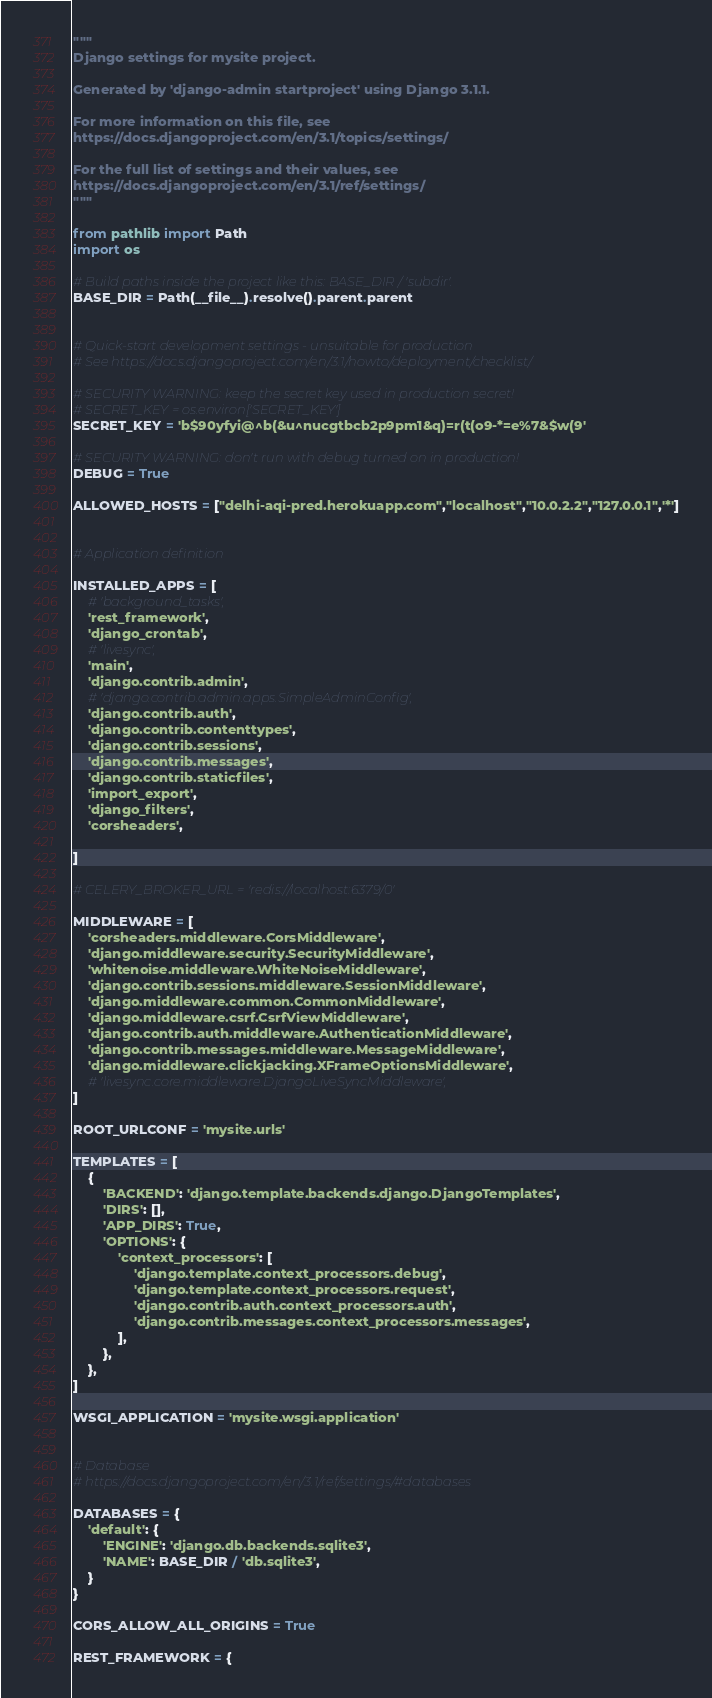<code> <loc_0><loc_0><loc_500><loc_500><_Python_>"""
Django settings for mysite project.

Generated by 'django-admin startproject' using Django 3.1.1.

For more information on this file, see
https://docs.djangoproject.com/en/3.1/topics/settings/

For the full list of settings and their values, see
https://docs.djangoproject.com/en/3.1/ref/settings/
"""

from pathlib import Path
import os

# Build paths inside the project like this: BASE_DIR / 'subdir'.
BASE_DIR = Path(__file__).resolve().parent.parent


# Quick-start development settings - unsuitable for production
# See https://docs.djangoproject.com/en/3.1/howto/deployment/checklist/

# SECURITY WARNING: keep the secret key used in production secret!
# SECRET_KEY = os.environ['SECRET_KEY']
SECRET_KEY = 'b$90yfyi@^b(&u^nucgtbcb2p9pm1&q)=r(t(o9-*=e%7&$w(9'

# SECURITY WARNING: don't run with debug turned on in production!
DEBUG = True

ALLOWED_HOSTS = ["delhi-aqi-pred.herokuapp.com","localhost","10.0.2.2","127.0.0.1",'*']


# Application definition

INSTALLED_APPS = [
    # 'background_tasks',
    'rest_framework',
    'django_crontab',
    # 'livesync',
    'main',
    'django.contrib.admin',
    # 'django.contrib.admin.apps.SimpleAdminConfig',
    'django.contrib.auth',
    'django.contrib.contenttypes',
    'django.contrib.sessions',
    'django.contrib.messages',
    'django.contrib.staticfiles',
    'import_export',
    'django_filters',
    'corsheaders',

]

# CELERY_BROKER_URL = 'redis://localhost:6379/0'

MIDDLEWARE = [
    'corsheaders.middleware.CorsMiddleware',
    'django.middleware.security.SecurityMiddleware',
    'whitenoise.middleware.WhiteNoiseMiddleware',
    'django.contrib.sessions.middleware.SessionMiddleware',
    'django.middleware.common.CommonMiddleware',
    'django.middleware.csrf.CsrfViewMiddleware',
    'django.contrib.auth.middleware.AuthenticationMiddleware',
    'django.contrib.messages.middleware.MessageMiddleware',
    'django.middleware.clickjacking.XFrameOptionsMiddleware',
    # 'livesync.core.middleware.DjangoLiveSyncMiddleware',
]

ROOT_URLCONF = 'mysite.urls'

TEMPLATES = [
    {
        'BACKEND': 'django.template.backends.django.DjangoTemplates',
        'DIRS': [],
        'APP_DIRS': True,
        'OPTIONS': {
            'context_processors': [
                'django.template.context_processors.debug',
                'django.template.context_processors.request',
                'django.contrib.auth.context_processors.auth',
                'django.contrib.messages.context_processors.messages',
            ],
        },
    },
]

WSGI_APPLICATION = 'mysite.wsgi.application'


# Database
# https://docs.djangoproject.com/en/3.1/ref/settings/#databases

DATABASES = {
    'default': {
        'ENGINE': 'django.db.backends.sqlite3',
        'NAME': BASE_DIR / 'db.sqlite3',
    }
}

CORS_ALLOW_ALL_ORIGINS = True

REST_FRAMEWORK = {</code> 